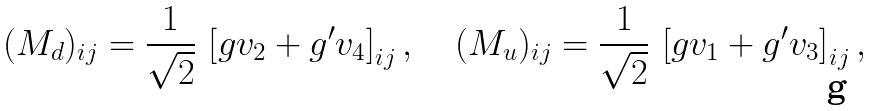Convert formula to latex. <formula><loc_0><loc_0><loc_500><loc_500>( M _ { d } ) _ { i j } = \frac { 1 } { \sqrt { 2 } } \, \left [ g v _ { 2 } + g ^ { \prime } v _ { 4 } \right ] _ { i j } , \quad ( M _ { u } ) _ { i j } = \frac { 1 } { \sqrt { 2 } } \, \left [ g v _ { 1 } + g ^ { \prime } v _ { 3 } \right ] _ { i j } ,</formula> 